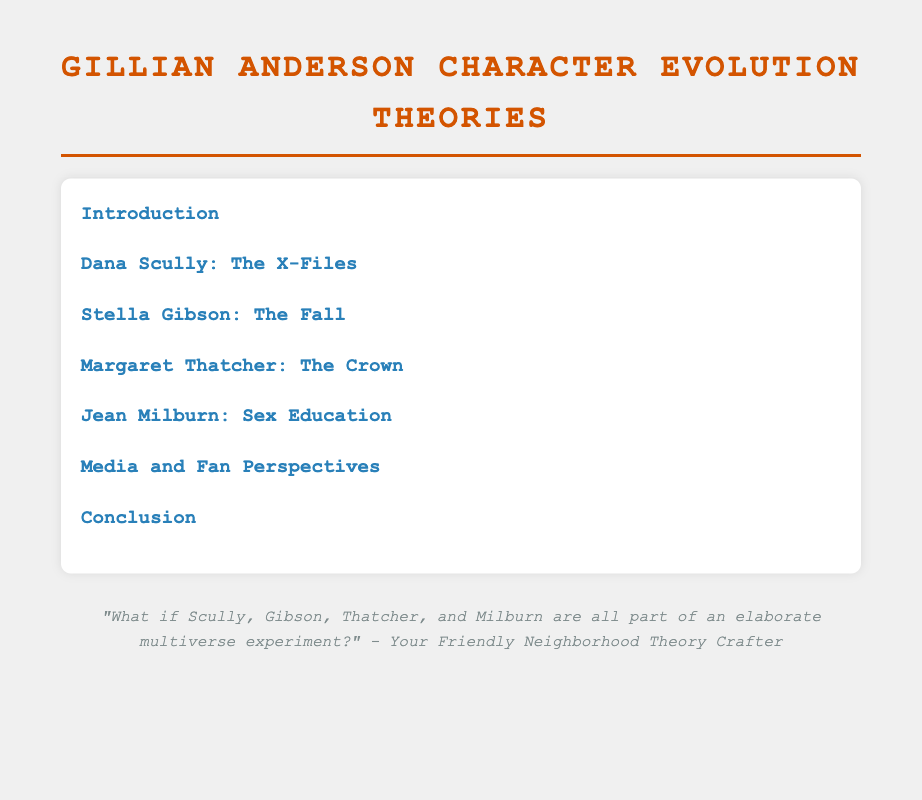What is the title of the document? The title is provided in the header section of the document, which is "Gillian Anderson Character Evolution Theories."
Answer: Gillian Anderson Character Evolution Theories How many key roles are analyzed in the document? The document discusses four key roles, as indicated by the chapters dedicated to each character.
Answer: Four What is the focus of the chapter on Dana Scully? The chapter focuses on her character traits and development throughout the series.
Answer: Character traits and development Which character is introduced in the chapter titled "Jean Milburn"? The chapter details the character Jean Milburn, as stated in the title.
Answer: Jean Milburn What type of perspectives does the document explore alongside character evolution? The document includes a section on media and fan perspectives regarding the character evolution.
Answer: Media and fan perspectives What is the last subsection listed under the Conclusion chapter? The last subsection summarizes final thoughts and insights about the character evolution study.
Answer: Final Thoughts and Insights Which character's growth is analyzed through complex cases? The document specifically mentions Gibson's growth being analyzed in relation to complex cases.
Answer: Gibson How does the document describe Stella Gibson's key traits? The introduction of Stella Gibson outlines her main characteristics which are explored in detail within the chapter.
Answer: Key Traits 